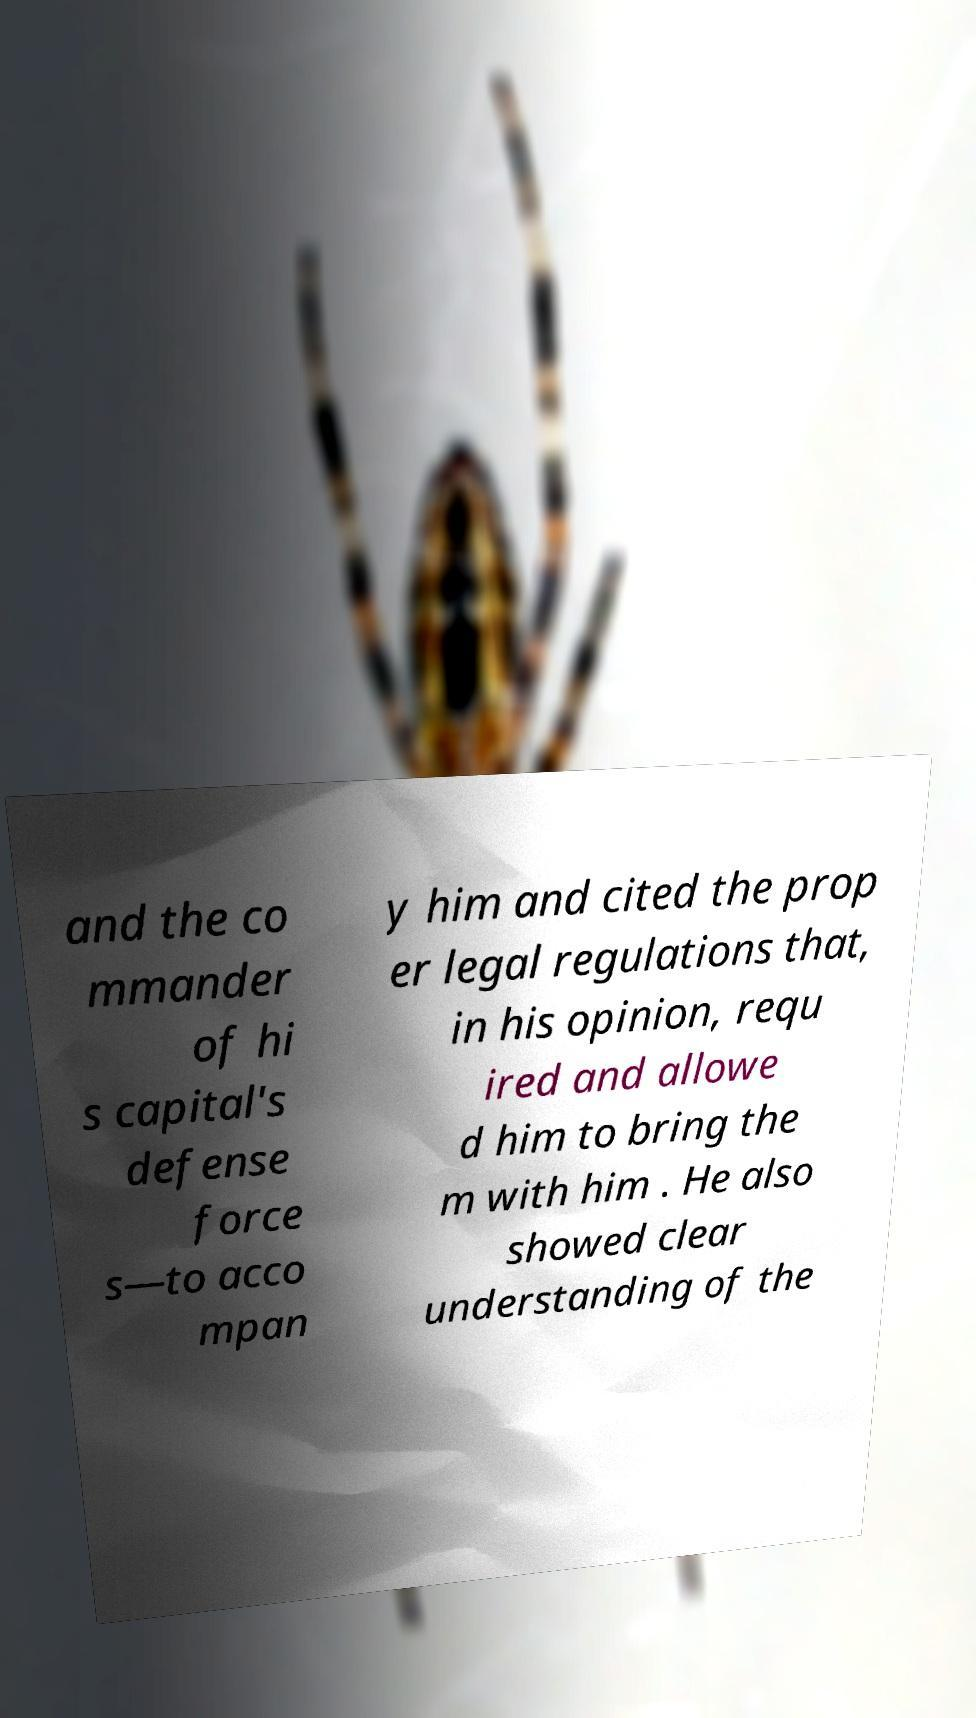Please identify and transcribe the text found in this image. and the co mmander of hi s capital's defense force s—to acco mpan y him and cited the prop er legal regulations that, in his opinion, requ ired and allowe d him to bring the m with him . He also showed clear understanding of the 